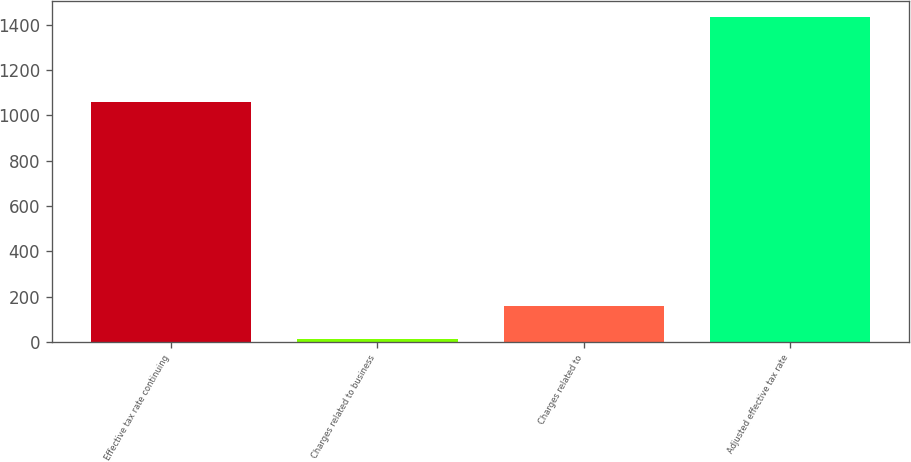<chart> <loc_0><loc_0><loc_500><loc_500><bar_chart><fcel>Effective tax rate continuing<fcel>Charges related to business<fcel>Charges related to<fcel>Adjusted effective tax rate<nl><fcel>1057<fcel>11<fcel>159<fcel>1435<nl></chart> 